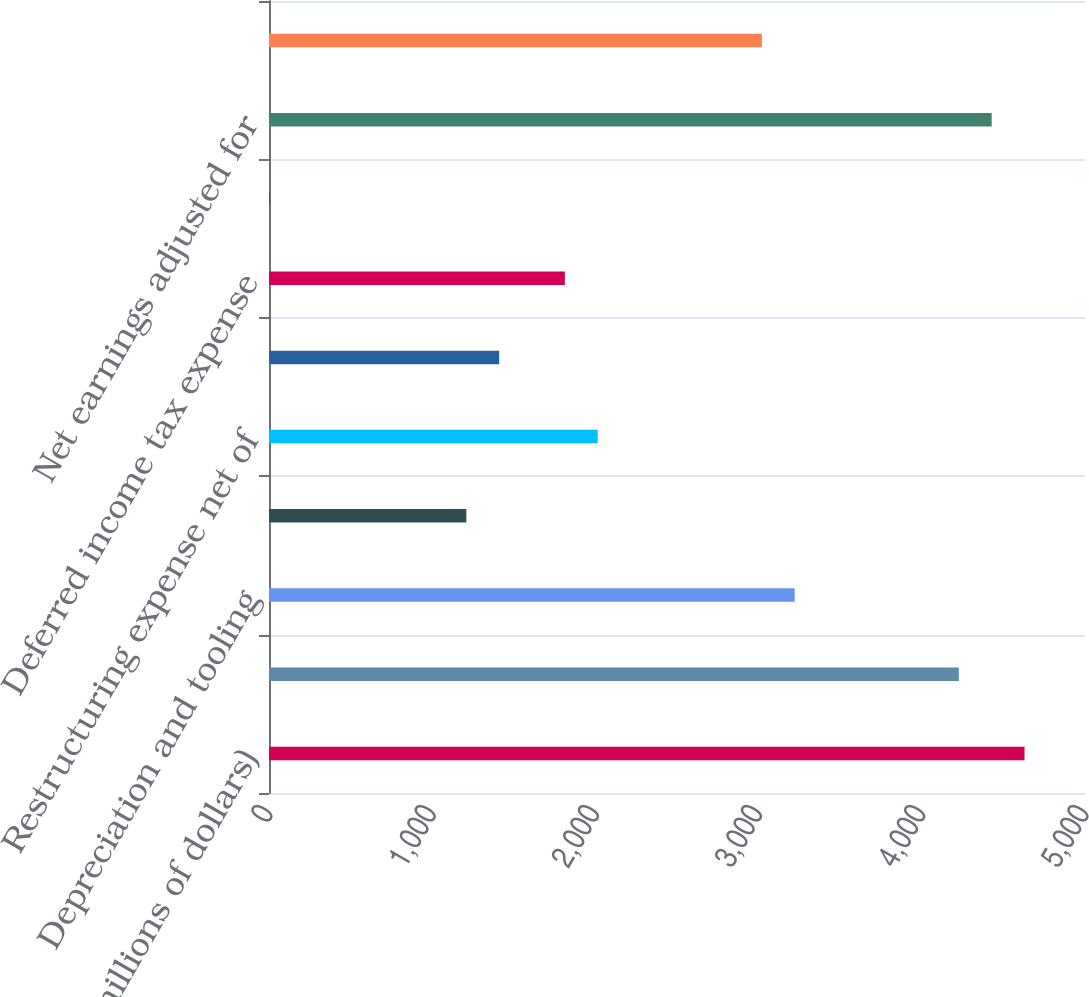<chart> <loc_0><loc_0><loc_500><loc_500><bar_chart><fcel>(in millions of dollars)<fcel>Net earnings<fcel>Depreciation and tooling<fcel>Amortization of intangible<fcel>Restructuring expense net of<fcel>Stock-based compensation<fcel>Deferred income tax expense<fcel>Equity in affiliates' earnings<fcel>Net earnings adjusted for<fcel>Receivables<nl><fcel>4629.47<fcel>4227.09<fcel>3221.14<fcel>1209.24<fcel>2014<fcel>1410.43<fcel>1812.81<fcel>2.1<fcel>4428.28<fcel>3019.95<nl></chart> 